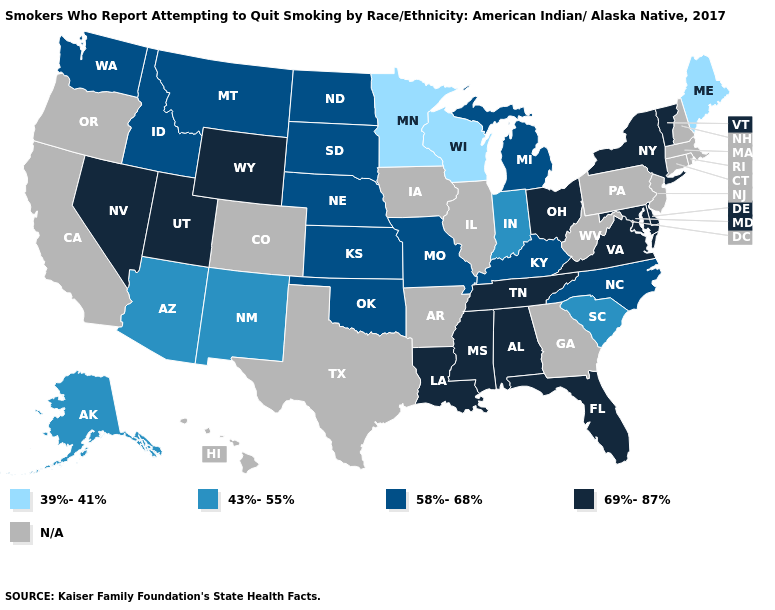Name the states that have a value in the range N/A?
Keep it brief. Arkansas, California, Colorado, Connecticut, Georgia, Hawaii, Illinois, Iowa, Massachusetts, New Hampshire, New Jersey, Oregon, Pennsylvania, Rhode Island, Texas, West Virginia. Which states hav the highest value in the South?
Write a very short answer. Alabama, Delaware, Florida, Louisiana, Maryland, Mississippi, Tennessee, Virginia. Does the first symbol in the legend represent the smallest category?
Keep it brief. Yes. Which states hav the highest value in the Northeast?
Keep it brief. New York, Vermont. Does the first symbol in the legend represent the smallest category?
Keep it brief. Yes. Does North Carolina have the lowest value in the South?
Write a very short answer. No. What is the value of Iowa?
Keep it brief. N/A. What is the lowest value in the USA?
Short answer required. 39%-41%. What is the value of Delaware?
Give a very brief answer. 69%-87%. Does the first symbol in the legend represent the smallest category?
Be succinct. Yes. Does the map have missing data?
Give a very brief answer. Yes. What is the value of New Hampshire?
Write a very short answer. N/A. Which states have the lowest value in the West?
Short answer required. Alaska, Arizona, New Mexico. 